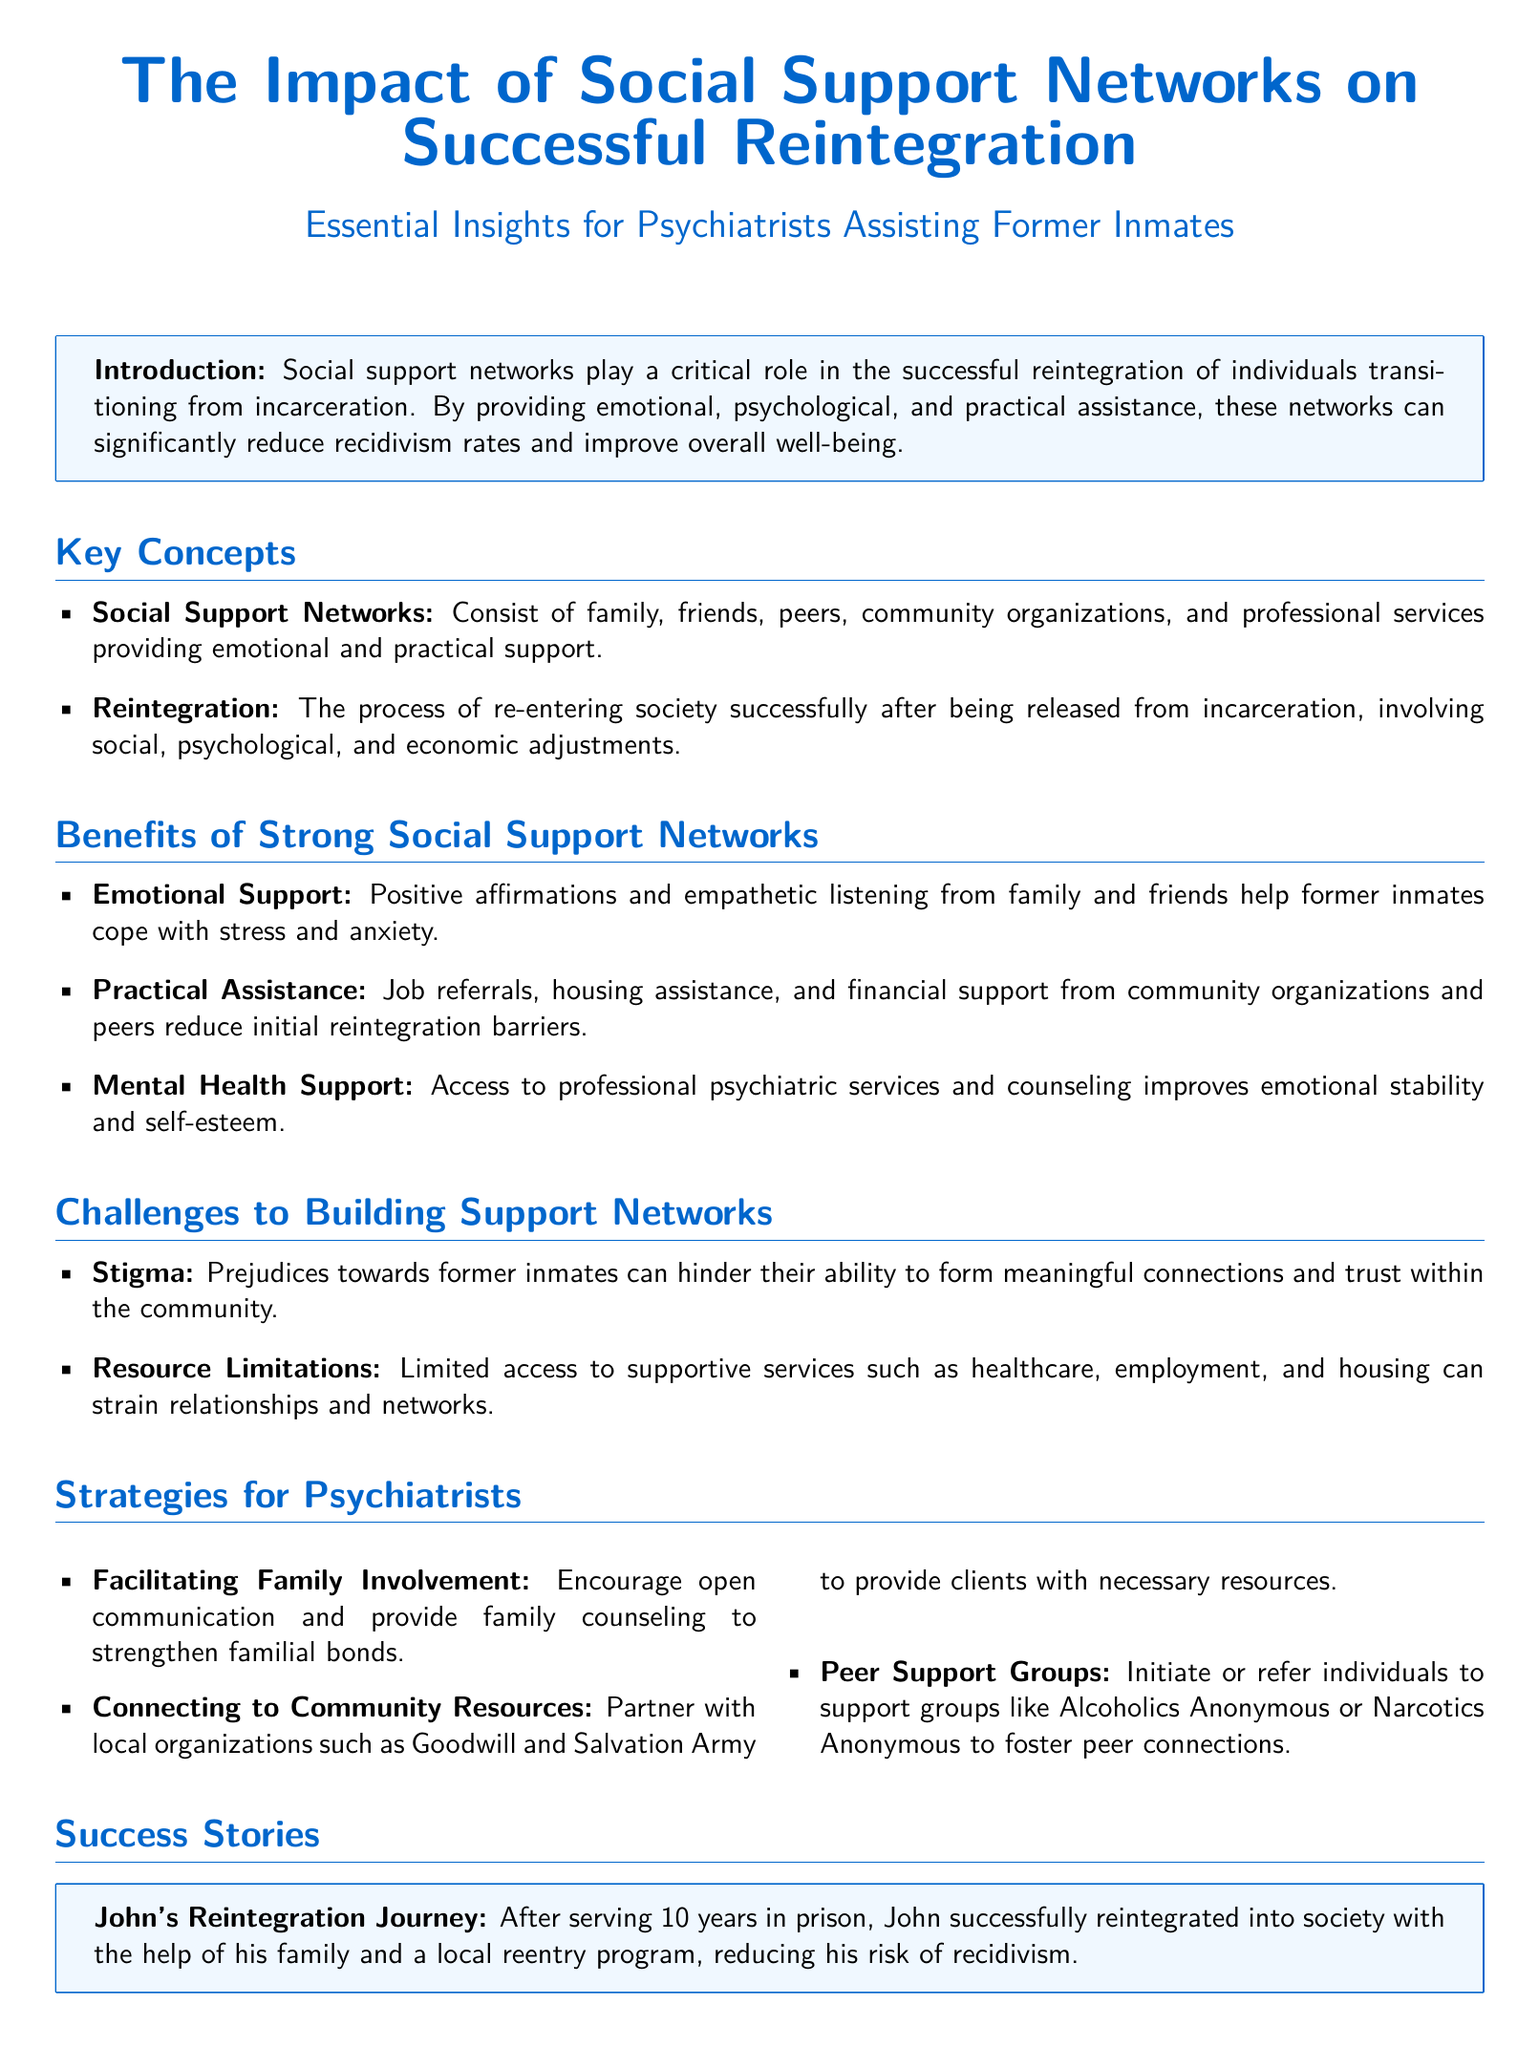What is the title of the document? The title of the document is presented prominently at the beginning of the rendered document.
Answer: The Impact of Social Support Networks on Successful Reintegration What is the color used for the main headings? The document specifies the RGB values for the main headings, indicating the color used.
Answer: RGB(0,102,204) What is a benefit of strong social support networks? The document lists several benefits, including one specifically related to emotional support.
Answer: Emotional Support Who can provide practical assistance to former inmates? The document mentions organizations that help with practical support during reintegration.
Answer: Community organizations What is a challenge to building support networks? The document identifies several challenges, including societal perceptions that affect relationships.
Answer: Stigma Which local organizations can psychiatrists partner with? The document suggests several community organizations that can assist in reintegration efforts.
Answer: Goodwill and Salvation Army What type of support groups are beneficial for former inmates? The document refers to specific support groups that help foster connections among peers.
Answer: Alcoholics Anonymous or Narcotics Anonymous What is the primary focus of SAMHSA's GAINS Center? The document briefly mentions the goals of this organization related to mental health services.
Answer: Expanding access to mental health and substance use services 